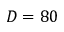<formula> <loc_0><loc_0><loc_500><loc_500>D = 8 0</formula> 